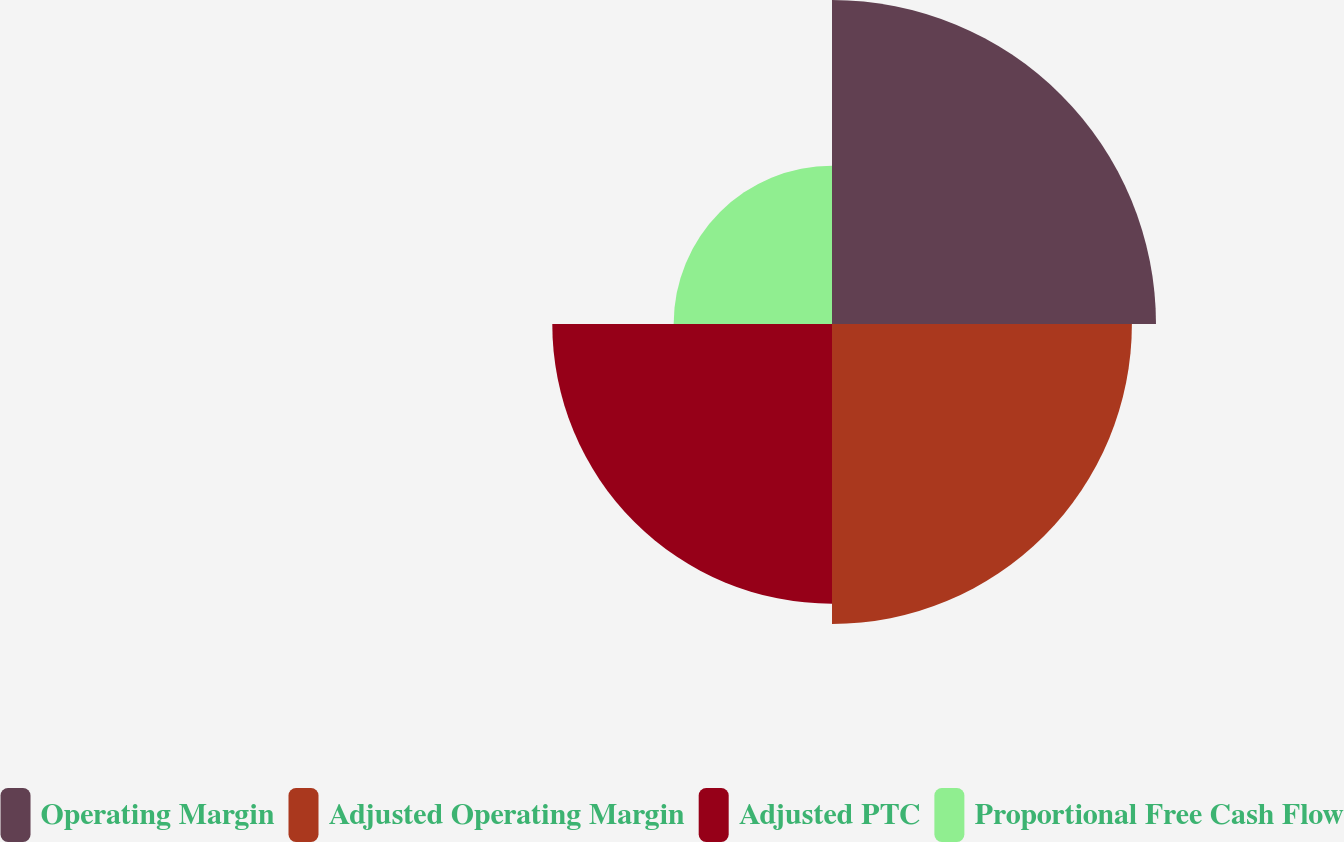<chart> <loc_0><loc_0><loc_500><loc_500><pie_chart><fcel>Operating Margin<fcel>Adjusted Operating Margin<fcel>Adjusted PTC<fcel>Proportional Free Cash Flow<nl><fcel>30.51%<fcel>28.24%<fcel>26.34%<fcel>14.91%<nl></chart> 